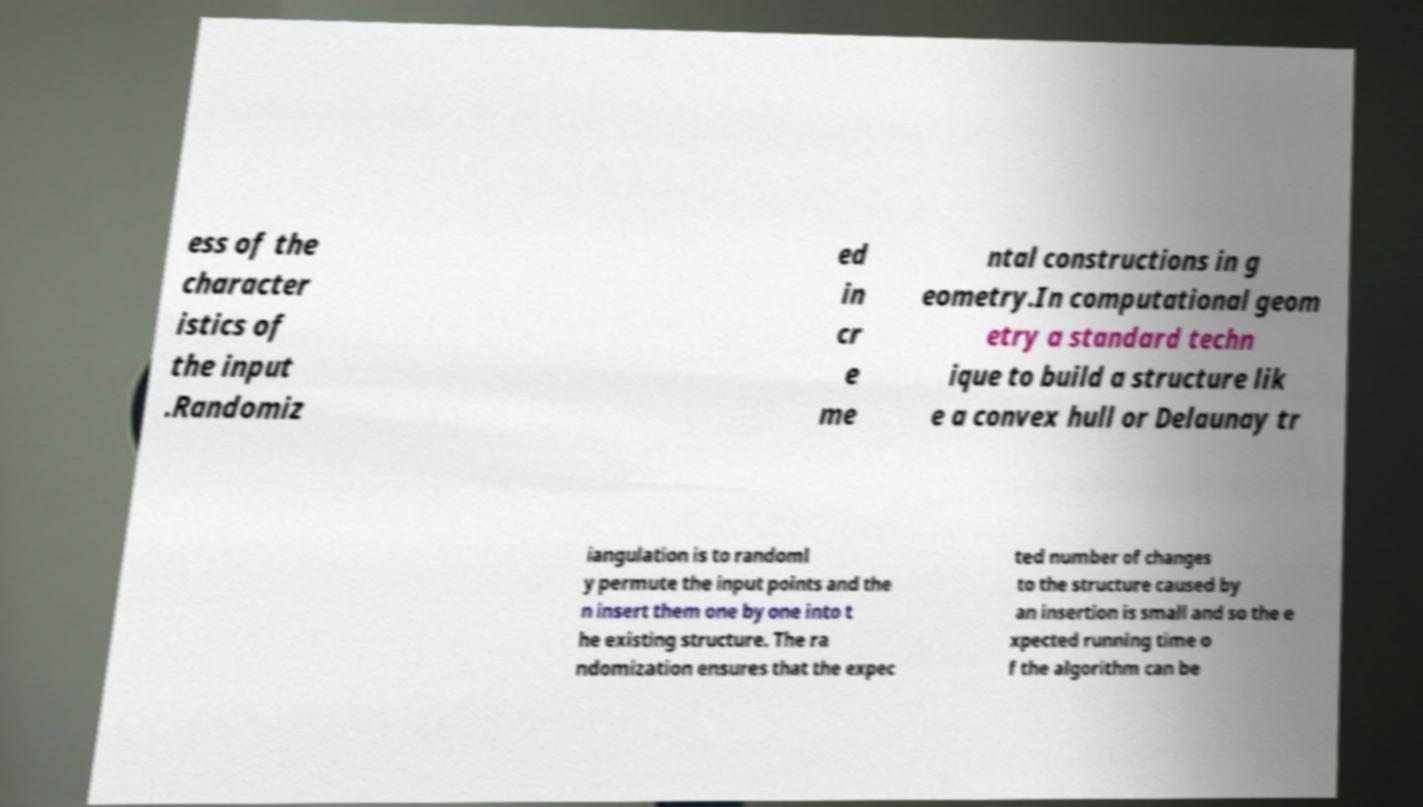Please read and relay the text visible in this image. What does it say? ess of the character istics of the input .Randomiz ed in cr e me ntal constructions in g eometry.In computational geom etry a standard techn ique to build a structure lik e a convex hull or Delaunay tr iangulation is to randoml y permute the input points and the n insert them one by one into t he existing structure. The ra ndomization ensures that the expec ted number of changes to the structure caused by an insertion is small and so the e xpected running time o f the algorithm can be 